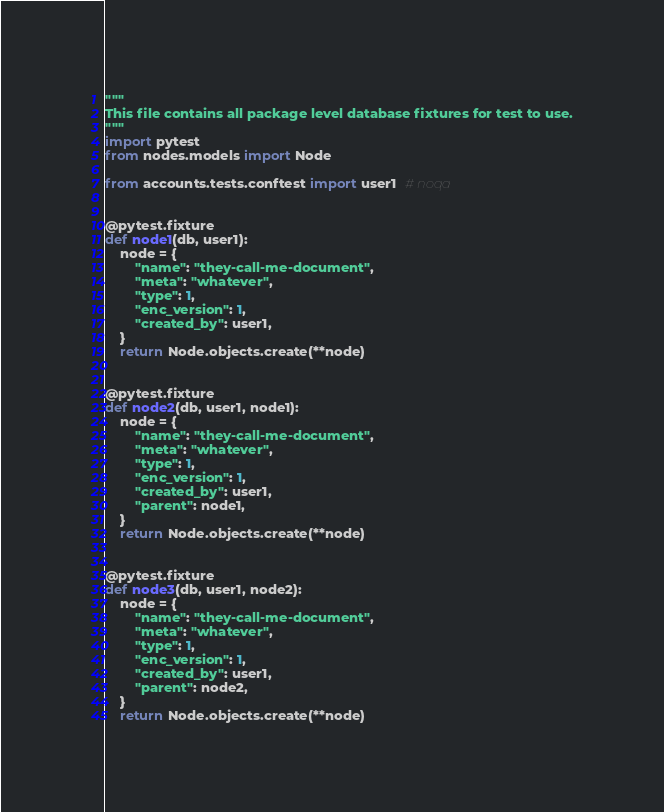Convert code to text. <code><loc_0><loc_0><loc_500><loc_500><_Python_>"""
This file contains all package level database fixtures for test to use.
"""
import pytest
from nodes.models import Node

from accounts.tests.conftest import user1  # noqa


@pytest.fixture
def node1(db, user1):
    node = {
        "name": "they-call-me-document",
        "meta": "whatever",
        "type": 1,
        "enc_version": 1,
        "created_by": user1,
    }
    return Node.objects.create(**node)


@pytest.fixture
def node2(db, user1, node1):
    node = {
        "name": "they-call-me-document",
        "meta": "whatever",
        "type": 1,
        "enc_version": 1,
        "created_by": user1,
        "parent": node1,
    }
    return Node.objects.create(**node)


@pytest.fixture
def node3(db, user1, node2):
    node = {
        "name": "they-call-me-document",
        "meta": "whatever",
        "type": 1,
        "enc_version": 1,
        "created_by": user1,
        "parent": node2,
    }
    return Node.objects.create(**node)
</code> 